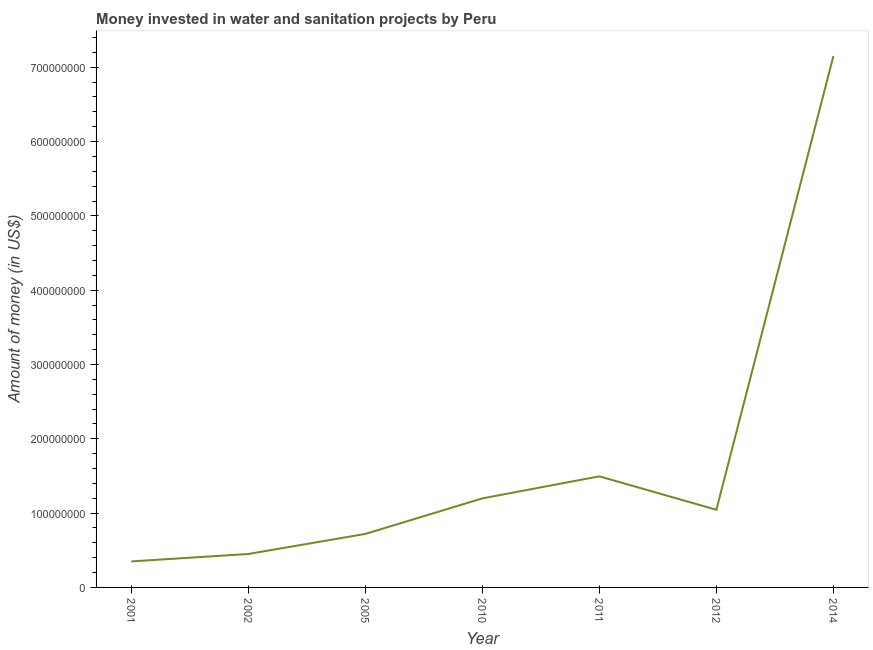What is the investment in 2005?
Make the answer very short. 7.20e+07. Across all years, what is the maximum investment?
Offer a terse response. 7.15e+08. Across all years, what is the minimum investment?
Keep it short and to the point. 3.50e+07. What is the sum of the investment?
Keep it short and to the point. 1.24e+09. What is the difference between the investment in 2002 and 2011?
Provide a short and direct response. -1.04e+08. What is the average investment per year?
Provide a short and direct response. 1.77e+08. What is the median investment?
Make the answer very short. 1.04e+08. What is the ratio of the investment in 2010 to that in 2014?
Offer a very short reply. 0.17. Is the difference between the investment in 2011 and 2014 greater than the difference between any two years?
Give a very brief answer. No. What is the difference between the highest and the second highest investment?
Give a very brief answer. 5.66e+08. What is the difference between the highest and the lowest investment?
Keep it short and to the point. 6.80e+08. Does the investment monotonically increase over the years?
Ensure brevity in your answer.  No. What is the difference between two consecutive major ticks on the Y-axis?
Give a very brief answer. 1.00e+08. Does the graph contain any zero values?
Your answer should be very brief. No. Does the graph contain grids?
Keep it short and to the point. No. What is the title of the graph?
Provide a short and direct response. Money invested in water and sanitation projects by Peru. What is the label or title of the X-axis?
Keep it short and to the point. Year. What is the label or title of the Y-axis?
Your answer should be very brief. Amount of money (in US$). What is the Amount of money (in US$) of 2001?
Ensure brevity in your answer.  3.50e+07. What is the Amount of money (in US$) of 2002?
Make the answer very short. 4.50e+07. What is the Amount of money (in US$) in 2005?
Keep it short and to the point. 7.20e+07. What is the Amount of money (in US$) of 2010?
Offer a terse response. 1.20e+08. What is the Amount of money (in US$) of 2011?
Ensure brevity in your answer.  1.50e+08. What is the Amount of money (in US$) in 2012?
Ensure brevity in your answer.  1.04e+08. What is the Amount of money (in US$) in 2014?
Keep it short and to the point. 7.15e+08. What is the difference between the Amount of money (in US$) in 2001 and 2002?
Offer a terse response. -1.00e+07. What is the difference between the Amount of money (in US$) in 2001 and 2005?
Offer a terse response. -3.70e+07. What is the difference between the Amount of money (in US$) in 2001 and 2010?
Offer a very short reply. -8.48e+07. What is the difference between the Amount of money (in US$) in 2001 and 2011?
Provide a short and direct response. -1.14e+08. What is the difference between the Amount of money (in US$) in 2001 and 2012?
Keep it short and to the point. -6.95e+07. What is the difference between the Amount of money (in US$) in 2001 and 2014?
Your answer should be compact. -6.80e+08. What is the difference between the Amount of money (in US$) in 2002 and 2005?
Keep it short and to the point. -2.70e+07. What is the difference between the Amount of money (in US$) in 2002 and 2010?
Give a very brief answer. -7.48e+07. What is the difference between the Amount of money (in US$) in 2002 and 2011?
Provide a short and direct response. -1.04e+08. What is the difference between the Amount of money (in US$) in 2002 and 2012?
Your answer should be very brief. -5.95e+07. What is the difference between the Amount of money (in US$) in 2002 and 2014?
Offer a very short reply. -6.70e+08. What is the difference between the Amount of money (in US$) in 2005 and 2010?
Your response must be concise. -4.78e+07. What is the difference between the Amount of money (in US$) in 2005 and 2011?
Provide a succinct answer. -7.75e+07. What is the difference between the Amount of money (in US$) in 2005 and 2012?
Provide a succinct answer. -3.25e+07. What is the difference between the Amount of money (in US$) in 2005 and 2014?
Provide a succinct answer. -6.43e+08. What is the difference between the Amount of money (in US$) in 2010 and 2011?
Make the answer very short. -2.97e+07. What is the difference between the Amount of money (in US$) in 2010 and 2012?
Your response must be concise. 1.53e+07. What is the difference between the Amount of money (in US$) in 2010 and 2014?
Keep it short and to the point. -5.95e+08. What is the difference between the Amount of money (in US$) in 2011 and 2012?
Your answer should be compact. 4.50e+07. What is the difference between the Amount of money (in US$) in 2011 and 2014?
Your response must be concise. -5.66e+08. What is the difference between the Amount of money (in US$) in 2012 and 2014?
Give a very brief answer. -6.10e+08. What is the ratio of the Amount of money (in US$) in 2001 to that in 2002?
Give a very brief answer. 0.78. What is the ratio of the Amount of money (in US$) in 2001 to that in 2005?
Provide a short and direct response. 0.49. What is the ratio of the Amount of money (in US$) in 2001 to that in 2010?
Keep it short and to the point. 0.29. What is the ratio of the Amount of money (in US$) in 2001 to that in 2011?
Your answer should be compact. 0.23. What is the ratio of the Amount of money (in US$) in 2001 to that in 2012?
Offer a very short reply. 0.34. What is the ratio of the Amount of money (in US$) in 2001 to that in 2014?
Make the answer very short. 0.05. What is the ratio of the Amount of money (in US$) in 2002 to that in 2010?
Offer a terse response. 0.38. What is the ratio of the Amount of money (in US$) in 2002 to that in 2011?
Your answer should be very brief. 0.3. What is the ratio of the Amount of money (in US$) in 2002 to that in 2012?
Offer a terse response. 0.43. What is the ratio of the Amount of money (in US$) in 2002 to that in 2014?
Offer a very short reply. 0.06. What is the ratio of the Amount of money (in US$) in 2005 to that in 2010?
Make the answer very short. 0.6. What is the ratio of the Amount of money (in US$) in 2005 to that in 2011?
Give a very brief answer. 0.48. What is the ratio of the Amount of money (in US$) in 2005 to that in 2012?
Ensure brevity in your answer.  0.69. What is the ratio of the Amount of money (in US$) in 2005 to that in 2014?
Offer a very short reply. 0.1. What is the ratio of the Amount of money (in US$) in 2010 to that in 2011?
Provide a succinct answer. 0.8. What is the ratio of the Amount of money (in US$) in 2010 to that in 2012?
Give a very brief answer. 1.15. What is the ratio of the Amount of money (in US$) in 2010 to that in 2014?
Provide a succinct answer. 0.17. What is the ratio of the Amount of money (in US$) in 2011 to that in 2012?
Ensure brevity in your answer.  1.43. What is the ratio of the Amount of money (in US$) in 2011 to that in 2014?
Offer a very short reply. 0.21. What is the ratio of the Amount of money (in US$) in 2012 to that in 2014?
Offer a terse response. 0.15. 